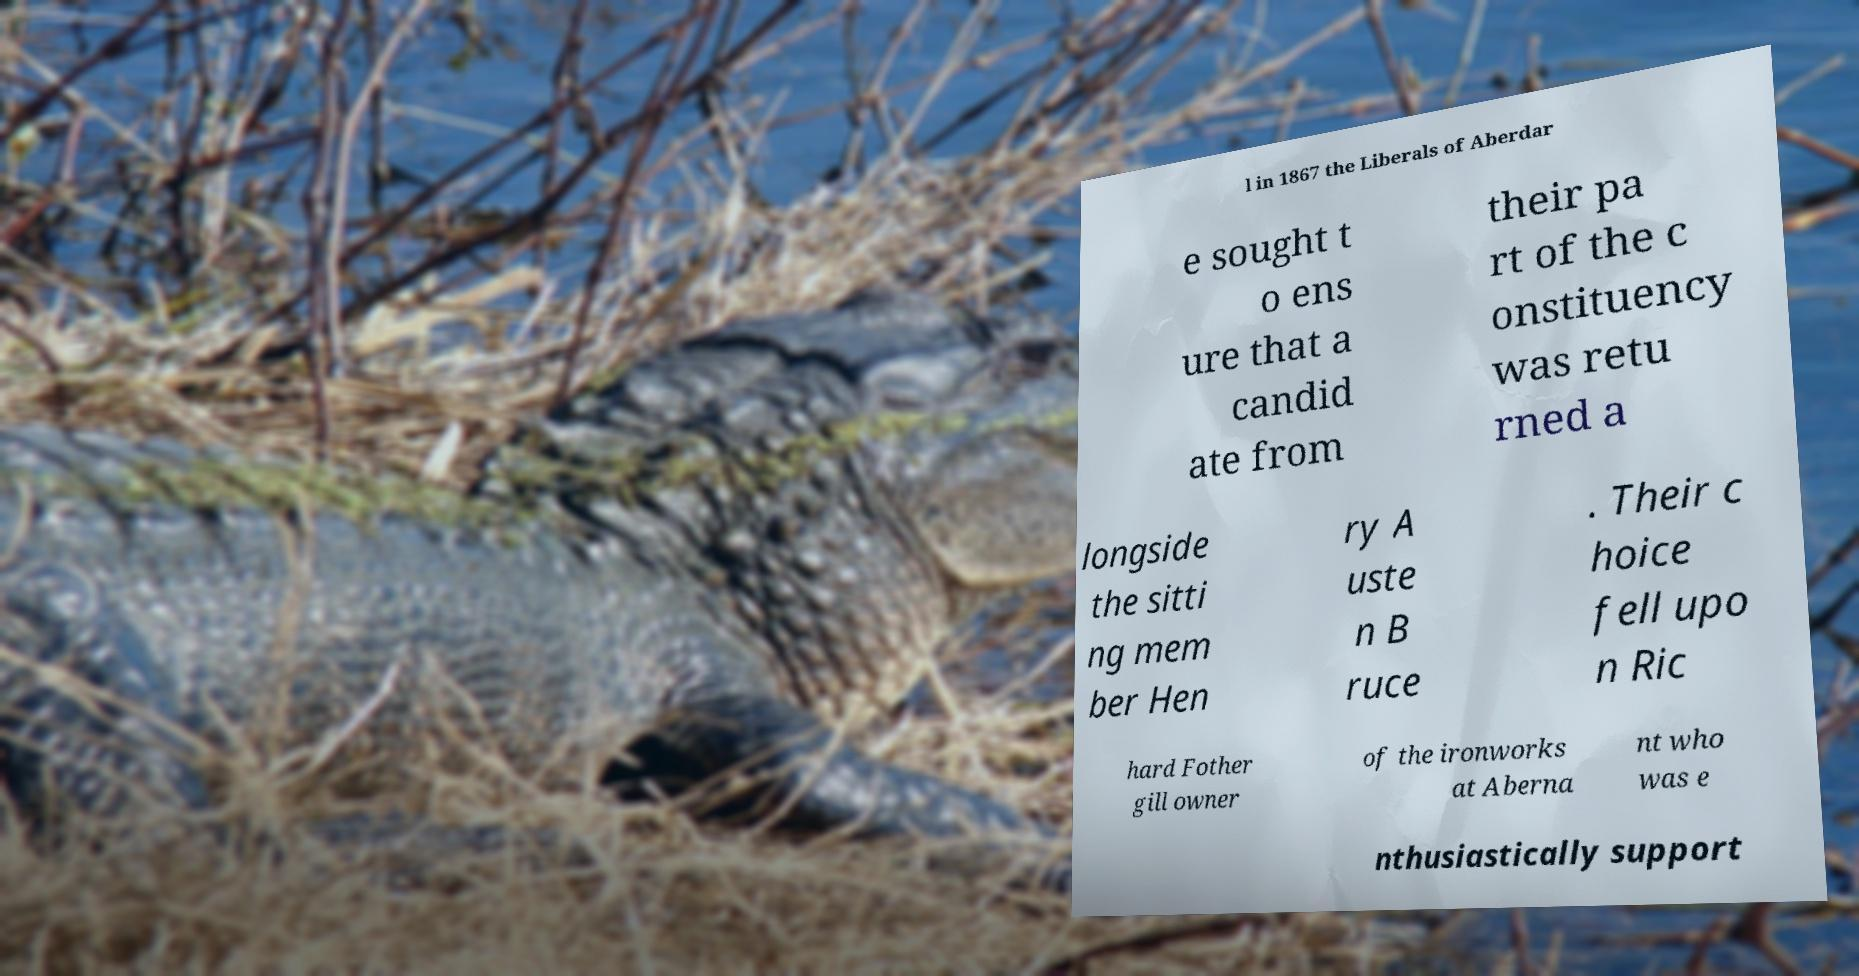There's text embedded in this image that I need extracted. Can you transcribe it verbatim? l in 1867 the Liberals of Aberdar e sought t o ens ure that a candid ate from their pa rt of the c onstituency was retu rned a longside the sitti ng mem ber Hen ry A uste n B ruce . Their c hoice fell upo n Ric hard Fother gill owner of the ironworks at Aberna nt who was e nthusiastically support 